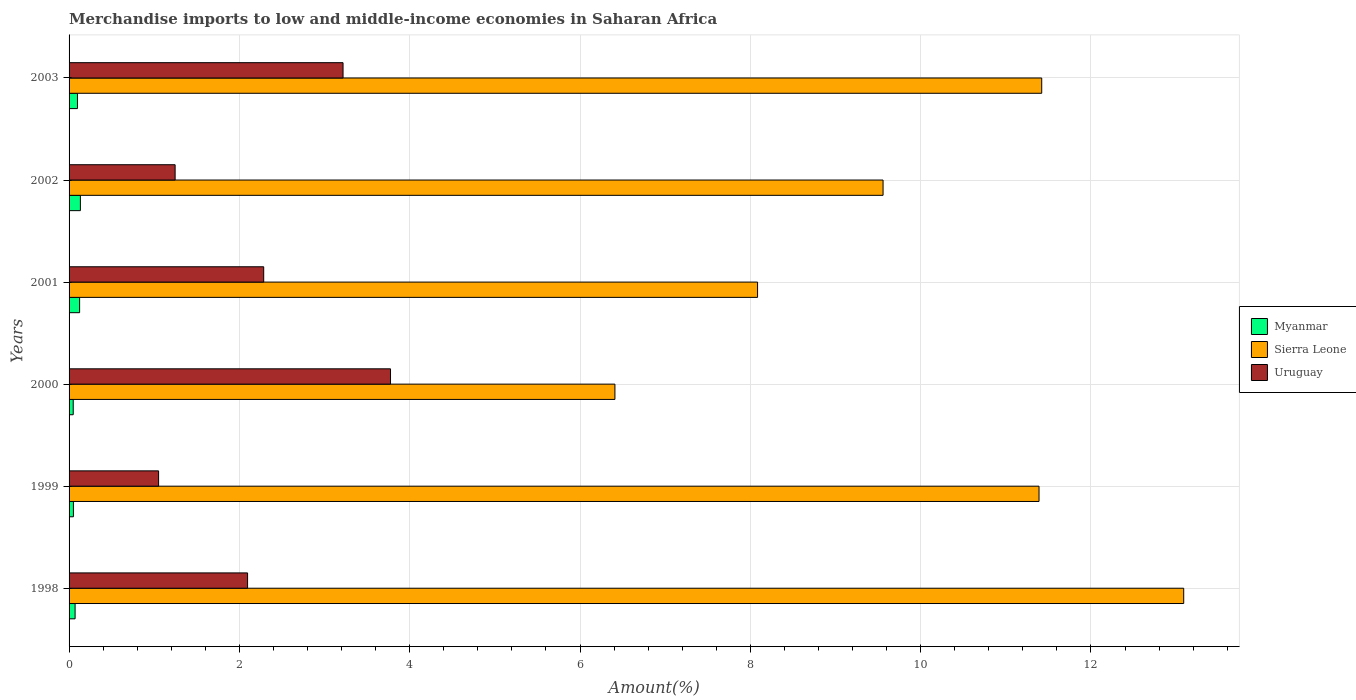How many groups of bars are there?
Provide a succinct answer. 6. In how many cases, is the number of bars for a given year not equal to the number of legend labels?
Provide a succinct answer. 0. What is the percentage of amount earned from merchandise imports in Uruguay in 1999?
Provide a succinct answer. 1.05. Across all years, what is the maximum percentage of amount earned from merchandise imports in Myanmar?
Provide a short and direct response. 0.13. Across all years, what is the minimum percentage of amount earned from merchandise imports in Myanmar?
Offer a terse response. 0.05. In which year was the percentage of amount earned from merchandise imports in Uruguay maximum?
Give a very brief answer. 2000. What is the total percentage of amount earned from merchandise imports in Uruguay in the graph?
Ensure brevity in your answer.  13.67. What is the difference between the percentage of amount earned from merchandise imports in Myanmar in 2000 and that in 2002?
Ensure brevity in your answer.  -0.08. What is the difference between the percentage of amount earned from merchandise imports in Sierra Leone in 2000 and the percentage of amount earned from merchandise imports in Myanmar in 2003?
Keep it short and to the point. 6.31. What is the average percentage of amount earned from merchandise imports in Myanmar per year?
Offer a terse response. 0.09. In the year 2003, what is the difference between the percentage of amount earned from merchandise imports in Myanmar and percentage of amount earned from merchandise imports in Uruguay?
Your answer should be very brief. -3.12. In how many years, is the percentage of amount earned from merchandise imports in Sierra Leone greater than 4 %?
Offer a terse response. 6. What is the ratio of the percentage of amount earned from merchandise imports in Myanmar in 2001 to that in 2002?
Ensure brevity in your answer.  0.93. Is the difference between the percentage of amount earned from merchandise imports in Myanmar in 1999 and 2002 greater than the difference between the percentage of amount earned from merchandise imports in Uruguay in 1999 and 2002?
Make the answer very short. Yes. What is the difference between the highest and the second highest percentage of amount earned from merchandise imports in Uruguay?
Your response must be concise. 0.56. What is the difference between the highest and the lowest percentage of amount earned from merchandise imports in Sierra Leone?
Provide a succinct answer. 6.68. In how many years, is the percentage of amount earned from merchandise imports in Uruguay greater than the average percentage of amount earned from merchandise imports in Uruguay taken over all years?
Provide a short and direct response. 3. What does the 1st bar from the top in 2000 represents?
Your answer should be compact. Uruguay. What does the 3rd bar from the bottom in 2000 represents?
Your response must be concise. Uruguay. Is it the case that in every year, the sum of the percentage of amount earned from merchandise imports in Sierra Leone and percentage of amount earned from merchandise imports in Uruguay is greater than the percentage of amount earned from merchandise imports in Myanmar?
Offer a very short reply. Yes. How many bars are there?
Ensure brevity in your answer.  18. Are all the bars in the graph horizontal?
Keep it short and to the point. Yes. Does the graph contain grids?
Provide a succinct answer. Yes. How many legend labels are there?
Provide a succinct answer. 3. What is the title of the graph?
Your answer should be very brief. Merchandise imports to low and middle-income economies in Saharan Africa. Does "Palau" appear as one of the legend labels in the graph?
Give a very brief answer. No. What is the label or title of the X-axis?
Your response must be concise. Amount(%). What is the Amount(%) of Myanmar in 1998?
Give a very brief answer. 0.07. What is the Amount(%) in Sierra Leone in 1998?
Offer a very short reply. 13.09. What is the Amount(%) in Uruguay in 1998?
Provide a short and direct response. 2.1. What is the Amount(%) of Myanmar in 1999?
Your answer should be compact. 0.05. What is the Amount(%) in Sierra Leone in 1999?
Ensure brevity in your answer.  11.39. What is the Amount(%) in Uruguay in 1999?
Offer a terse response. 1.05. What is the Amount(%) in Myanmar in 2000?
Your answer should be compact. 0.05. What is the Amount(%) of Sierra Leone in 2000?
Offer a very short reply. 6.41. What is the Amount(%) of Uruguay in 2000?
Offer a very short reply. 3.77. What is the Amount(%) in Myanmar in 2001?
Your answer should be very brief. 0.12. What is the Amount(%) in Sierra Leone in 2001?
Offer a very short reply. 8.09. What is the Amount(%) of Uruguay in 2001?
Provide a short and direct response. 2.29. What is the Amount(%) in Myanmar in 2002?
Give a very brief answer. 0.13. What is the Amount(%) of Sierra Leone in 2002?
Keep it short and to the point. 9.56. What is the Amount(%) in Uruguay in 2002?
Offer a very short reply. 1.25. What is the Amount(%) of Myanmar in 2003?
Give a very brief answer. 0.1. What is the Amount(%) of Sierra Leone in 2003?
Provide a short and direct response. 11.42. What is the Amount(%) of Uruguay in 2003?
Ensure brevity in your answer.  3.22. Across all years, what is the maximum Amount(%) in Myanmar?
Keep it short and to the point. 0.13. Across all years, what is the maximum Amount(%) of Sierra Leone?
Provide a succinct answer. 13.09. Across all years, what is the maximum Amount(%) in Uruguay?
Your response must be concise. 3.77. Across all years, what is the minimum Amount(%) of Myanmar?
Ensure brevity in your answer.  0.05. Across all years, what is the minimum Amount(%) in Sierra Leone?
Provide a succinct answer. 6.41. Across all years, what is the minimum Amount(%) of Uruguay?
Offer a terse response. 1.05. What is the total Amount(%) in Myanmar in the graph?
Your answer should be very brief. 0.53. What is the total Amount(%) in Sierra Leone in the graph?
Your answer should be very brief. 59.96. What is the total Amount(%) of Uruguay in the graph?
Make the answer very short. 13.67. What is the difference between the Amount(%) of Myanmar in 1998 and that in 1999?
Your answer should be compact. 0.02. What is the difference between the Amount(%) of Sierra Leone in 1998 and that in 1999?
Give a very brief answer. 1.7. What is the difference between the Amount(%) in Uruguay in 1998 and that in 1999?
Your answer should be compact. 1.04. What is the difference between the Amount(%) in Myanmar in 1998 and that in 2000?
Your answer should be compact. 0.02. What is the difference between the Amount(%) of Sierra Leone in 1998 and that in 2000?
Provide a short and direct response. 6.68. What is the difference between the Amount(%) of Uruguay in 1998 and that in 2000?
Provide a succinct answer. -1.68. What is the difference between the Amount(%) in Myanmar in 1998 and that in 2001?
Ensure brevity in your answer.  -0.05. What is the difference between the Amount(%) of Sierra Leone in 1998 and that in 2001?
Keep it short and to the point. 5. What is the difference between the Amount(%) of Uruguay in 1998 and that in 2001?
Your response must be concise. -0.19. What is the difference between the Amount(%) in Myanmar in 1998 and that in 2002?
Your answer should be compact. -0.06. What is the difference between the Amount(%) of Sierra Leone in 1998 and that in 2002?
Provide a succinct answer. 3.53. What is the difference between the Amount(%) in Uruguay in 1998 and that in 2002?
Provide a succinct answer. 0.85. What is the difference between the Amount(%) of Myanmar in 1998 and that in 2003?
Ensure brevity in your answer.  -0.03. What is the difference between the Amount(%) in Sierra Leone in 1998 and that in 2003?
Your answer should be compact. 1.67. What is the difference between the Amount(%) in Uruguay in 1998 and that in 2003?
Offer a terse response. -1.12. What is the difference between the Amount(%) in Myanmar in 1999 and that in 2000?
Provide a short and direct response. 0. What is the difference between the Amount(%) of Sierra Leone in 1999 and that in 2000?
Provide a short and direct response. 4.98. What is the difference between the Amount(%) of Uruguay in 1999 and that in 2000?
Your response must be concise. -2.72. What is the difference between the Amount(%) in Myanmar in 1999 and that in 2001?
Make the answer very short. -0.07. What is the difference between the Amount(%) in Sierra Leone in 1999 and that in 2001?
Offer a very short reply. 3.31. What is the difference between the Amount(%) of Uruguay in 1999 and that in 2001?
Offer a terse response. -1.23. What is the difference between the Amount(%) of Myanmar in 1999 and that in 2002?
Provide a succinct answer. -0.08. What is the difference between the Amount(%) of Sierra Leone in 1999 and that in 2002?
Keep it short and to the point. 1.83. What is the difference between the Amount(%) of Uruguay in 1999 and that in 2002?
Your response must be concise. -0.19. What is the difference between the Amount(%) in Myanmar in 1999 and that in 2003?
Provide a short and direct response. -0.05. What is the difference between the Amount(%) of Sierra Leone in 1999 and that in 2003?
Provide a short and direct response. -0.03. What is the difference between the Amount(%) of Uruguay in 1999 and that in 2003?
Your answer should be very brief. -2.17. What is the difference between the Amount(%) in Myanmar in 2000 and that in 2001?
Give a very brief answer. -0.08. What is the difference between the Amount(%) of Sierra Leone in 2000 and that in 2001?
Provide a short and direct response. -1.68. What is the difference between the Amount(%) in Uruguay in 2000 and that in 2001?
Offer a terse response. 1.49. What is the difference between the Amount(%) in Myanmar in 2000 and that in 2002?
Provide a short and direct response. -0.08. What is the difference between the Amount(%) in Sierra Leone in 2000 and that in 2002?
Ensure brevity in your answer.  -3.15. What is the difference between the Amount(%) in Uruguay in 2000 and that in 2002?
Give a very brief answer. 2.53. What is the difference between the Amount(%) of Myanmar in 2000 and that in 2003?
Make the answer very short. -0.05. What is the difference between the Amount(%) in Sierra Leone in 2000 and that in 2003?
Your response must be concise. -5.01. What is the difference between the Amount(%) in Uruguay in 2000 and that in 2003?
Give a very brief answer. 0.56. What is the difference between the Amount(%) of Myanmar in 2001 and that in 2002?
Your answer should be very brief. -0.01. What is the difference between the Amount(%) of Sierra Leone in 2001 and that in 2002?
Offer a very short reply. -1.47. What is the difference between the Amount(%) of Uruguay in 2001 and that in 2002?
Ensure brevity in your answer.  1.04. What is the difference between the Amount(%) of Myanmar in 2001 and that in 2003?
Give a very brief answer. 0.03. What is the difference between the Amount(%) in Sierra Leone in 2001 and that in 2003?
Your answer should be compact. -3.34. What is the difference between the Amount(%) in Uruguay in 2001 and that in 2003?
Keep it short and to the point. -0.93. What is the difference between the Amount(%) of Myanmar in 2002 and that in 2003?
Give a very brief answer. 0.03. What is the difference between the Amount(%) in Sierra Leone in 2002 and that in 2003?
Your answer should be very brief. -1.86. What is the difference between the Amount(%) of Uruguay in 2002 and that in 2003?
Offer a very short reply. -1.97. What is the difference between the Amount(%) of Myanmar in 1998 and the Amount(%) of Sierra Leone in 1999?
Your response must be concise. -11.32. What is the difference between the Amount(%) of Myanmar in 1998 and the Amount(%) of Uruguay in 1999?
Provide a short and direct response. -0.98. What is the difference between the Amount(%) in Sierra Leone in 1998 and the Amount(%) in Uruguay in 1999?
Your answer should be very brief. 12.04. What is the difference between the Amount(%) in Myanmar in 1998 and the Amount(%) in Sierra Leone in 2000?
Provide a short and direct response. -6.34. What is the difference between the Amount(%) of Myanmar in 1998 and the Amount(%) of Uruguay in 2000?
Offer a very short reply. -3.7. What is the difference between the Amount(%) of Sierra Leone in 1998 and the Amount(%) of Uruguay in 2000?
Provide a short and direct response. 9.31. What is the difference between the Amount(%) of Myanmar in 1998 and the Amount(%) of Sierra Leone in 2001?
Provide a short and direct response. -8.01. What is the difference between the Amount(%) in Myanmar in 1998 and the Amount(%) in Uruguay in 2001?
Your answer should be very brief. -2.21. What is the difference between the Amount(%) of Sierra Leone in 1998 and the Amount(%) of Uruguay in 2001?
Offer a very short reply. 10.8. What is the difference between the Amount(%) of Myanmar in 1998 and the Amount(%) of Sierra Leone in 2002?
Your answer should be very brief. -9.49. What is the difference between the Amount(%) of Myanmar in 1998 and the Amount(%) of Uruguay in 2002?
Your answer should be compact. -1.17. What is the difference between the Amount(%) of Sierra Leone in 1998 and the Amount(%) of Uruguay in 2002?
Keep it short and to the point. 11.84. What is the difference between the Amount(%) of Myanmar in 1998 and the Amount(%) of Sierra Leone in 2003?
Make the answer very short. -11.35. What is the difference between the Amount(%) in Myanmar in 1998 and the Amount(%) in Uruguay in 2003?
Your response must be concise. -3.15. What is the difference between the Amount(%) of Sierra Leone in 1998 and the Amount(%) of Uruguay in 2003?
Make the answer very short. 9.87. What is the difference between the Amount(%) of Myanmar in 1999 and the Amount(%) of Sierra Leone in 2000?
Ensure brevity in your answer.  -6.36. What is the difference between the Amount(%) in Myanmar in 1999 and the Amount(%) in Uruguay in 2000?
Keep it short and to the point. -3.72. What is the difference between the Amount(%) of Sierra Leone in 1999 and the Amount(%) of Uruguay in 2000?
Provide a succinct answer. 7.62. What is the difference between the Amount(%) in Myanmar in 1999 and the Amount(%) in Sierra Leone in 2001?
Offer a terse response. -8.03. What is the difference between the Amount(%) of Myanmar in 1999 and the Amount(%) of Uruguay in 2001?
Provide a short and direct response. -2.23. What is the difference between the Amount(%) of Sierra Leone in 1999 and the Amount(%) of Uruguay in 2001?
Offer a terse response. 9.1. What is the difference between the Amount(%) in Myanmar in 1999 and the Amount(%) in Sierra Leone in 2002?
Make the answer very short. -9.51. What is the difference between the Amount(%) in Myanmar in 1999 and the Amount(%) in Uruguay in 2002?
Your response must be concise. -1.19. What is the difference between the Amount(%) in Sierra Leone in 1999 and the Amount(%) in Uruguay in 2002?
Ensure brevity in your answer.  10.14. What is the difference between the Amount(%) in Myanmar in 1999 and the Amount(%) in Sierra Leone in 2003?
Your answer should be very brief. -11.37. What is the difference between the Amount(%) in Myanmar in 1999 and the Amount(%) in Uruguay in 2003?
Your response must be concise. -3.17. What is the difference between the Amount(%) in Sierra Leone in 1999 and the Amount(%) in Uruguay in 2003?
Your answer should be compact. 8.17. What is the difference between the Amount(%) of Myanmar in 2000 and the Amount(%) of Sierra Leone in 2001?
Provide a short and direct response. -8.04. What is the difference between the Amount(%) of Myanmar in 2000 and the Amount(%) of Uruguay in 2001?
Provide a short and direct response. -2.24. What is the difference between the Amount(%) of Sierra Leone in 2000 and the Amount(%) of Uruguay in 2001?
Offer a very short reply. 4.12. What is the difference between the Amount(%) in Myanmar in 2000 and the Amount(%) in Sierra Leone in 2002?
Provide a short and direct response. -9.51. What is the difference between the Amount(%) of Myanmar in 2000 and the Amount(%) of Uruguay in 2002?
Your answer should be very brief. -1.2. What is the difference between the Amount(%) in Sierra Leone in 2000 and the Amount(%) in Uruguay in 2002?
Your response must be concise. 5.16. What is the difference between the Amount(%) in Myanmar in 2000 and the Amount(%) in Sierra Leone in 2003?
Your answer should be very brief. -11.37. What is the difference between the Amount(%) in Myanmar in 2000 and the Amount(%) in Uruguay in 2003?
Your response must be concise. -3.17. What is the difference between the Amount(%) in Sierra Leone in 2000 and the Amount(%) in Uruguay in 2003?
Your response must be concise. 3.19. What is the difference between the Amount(%) of Myanmar in 2001 and the Amount(%) of Sierra Leone in 2002?
Ensure brevity in your answer.  -9.44. What is the difference between the Amount(%) of Myanmar in 2001 and the Amount(%) of Uruguay in 2002?
Give a very brief answer. -1.12. What is the difference between the Amount(%) of Sierra Leone in 2001 and the Amount(%) of Uruguay in 2002?
Make the answer very short. 6.84. What is the difference between the Amount(%) of Myanmar in 2001 and the Amount(%) of Sierra Leone in 2003?
Make the answer very short. -11.3. What is the difference between the Amount(%) in Myanmar in 2001 and the Amount(%) in Uruguay in 2003?
Your response must be concise. -3.09. What is the difference between the Amount(%) of Sierra Leone in 2001 and the Amount(%) of Uruguay in 2003?
Give a very brief answer. 4.87. What is the difference between the Amount(%) in Myanmar in 2002 and the Amount(%) in Sierra Leone in 2003?
Provide a succinct answer. -11.29. What is the difference between the Amount(%) of Myanmar in 2002 and the Amount(%) of Uruguay in 2003?
Make the answer very short. -3.08. What is the difference between the Amount(%) of Sierra Leone in 2002 and the Amount(%) of Uruguay in 2003?
Make the answer very short. 6.34. What is the average Amount(%) in Myanmar per year?
Make the answer very short. 0.09. What is the average Amount(%) in Sierra Leone per year?
Provide a short and direct response. 9.99. What is the average Amount(%) of Uruguay per year?
Keep it short and to the point. 2.28. In the year 1998, what is the difference between the Amount(%) of Myanmar and Amount(%) of Sierra Leone?
Ensure brevity in your answer.  -13.02. In the year 1998, what is the difference between the Amount(%) in Myanmar and Amount(%) in Uruguay?
Ensure brevity in your answer.  -2.03. In the year 1998, what is the difference between the Amount(%) of Sierra Leone and Amount(%) of Uruguay?
Your response must be concise. 10.99. In the year 1999, what is the difference between the Amount(%) in Myanmar and Amount(%) in Sierra Leone?
Give a very brief answer. -11.34. In the year 1999, what is the difference between the Amount(%) of Myanmar and Amount(%) of Uruguay?
Offer a very short reply. -1. In the year 1999, what is the difference between the Amount(%) in Sierra Leone and Amount(%) in Uruguay?
Ensure brevity in your answer.  10.34. In the year 2000, what is the difference between the Amount(%) in Myanmar and Amount(%) in Sierra Leone?
Your response must be concise. -6.36. In the year 2000, what is the difference between the Amount(%) of Myanmar and Amount(%) of Uruguay?
Provide a short and direct response. -3.73. In the year 2000, what is the difference between the Amount(%) of Sierra Leone and Amount(%) of Uruguay?
Provide a succinct answer. 2.64. In the year 2001, what is the difference between the Amount(%) of Myanmar and Amount(%) of Sierra Leone?
Make the answer very short. -7.96. In the year 2001, what is the difference between the Amount(%) in Myanmar and Amount(%) in Uruguay?
Give a very brief answer. -2.16. In the year 2001, what is the difference between the Amount(%) of Sierra Leone and Amount(%) of Uruguay?
Make the answer very short. 5.8. In the year 2002, what is the difference between the Amount(%) in Myanmar and Amount(%) in Sierra Leone?
Offer a terse response. -9.43. In the year 2002, what is the difference between the Amount(%) in Myanmar and Amount(%) in Uruguay?
Give a very brief answer. -1.11. In the year 2002, what is the difference between the Amount(%) in Sierra Leone and Amount(%) in Uruguay?
Ensure brevity in your answer.  8.31. In the year 2003, what is the difference between the Amount(%) of Myanmar and Amount(%) of Sierra Leone?
Offer a terse response. -11.32. In the year 2003, what is the difference between the Amount(%) of Myanmar and Amount(%) of Uruguay?
Keep it short and to the point. -3.12. In the year 2003, what is the difference between the Amount(%) in Sierra Leone and Amount(%) in Uruguay?
Your answer should be compact. 8.2. What is the ratio of the Amount(%) of Myanmar in 1998 to that in 1999?
Keep it short and to the point. 1.39. What is the ratio of the Amount(%) of Sierra Leone in 1998 to that in 1999?
Make the answer very short. 1.15. What is the ratio of the Amount(%) in Uruguay in 1998 to that in 1999?
Keep it short and to the point. 1.99. What is the ratio of the Amount(%) of Myanmar in 1998 to that in 2000?
Your answer should be compact. 1.45. What is the ratio of the Amount(%) of Sierra Leone in 1998 to that in 2000?
Make the answer very short. 2.04. What is the ratio of the Amount(%) in Uruguay in 1998 to that in 2000?
Offer a terse response. 0.56. What is the ratio of the Amount(%) of Myanmar in 1998 to that in 2001?
Offer a terse response. 0.57. What is the ratio of the Amount(%) of Sierra Leone in 1998 to that in 2001?
Give a very brief answer. 1.62. What is the ratio of the Amount(%) in Uruguay in 1998 to that in 2001?
Offer a very short reply. 0.92. What is the ratio of the Amount(%) of Myanmar in 1998 to that in 2002?
Offer a very short reply. 0.53. What is the ratio of the Amount(%) of Sierra Leone in 1998 to that in 2002?
Provide a succinct answer. 1.37. What is the ratio of the Amount(%) of Uruguay in 1998 to that in 2002?
Your answer should be compact. 1.68. What is the ratio of the Amount(%) of Myanmar in 1998 to that in 2003?
Your response must be concise. 0.72. What is the ratio of the Amount(%) of Sierra Leone in 1998 to that in 2003?
Ensure brevity in your answer.  1.15. What is the ratio of the Amount(%) in Uruguay in 1998 to that in 2003?
Offer a very short reply. 0.65. What is the ratio of the Amount(%) in Myanmar in 1999 to that in 2000?
Keep it short and to the point. 1.05. What is the ratio of the Amount(%) in Sierra Leone in 1999 to that in 2000?
Make the answer very short. 1.78. What is the ratio of the Amount(%) in Uruguay in 1999 to that in 2000?
Ensure brevity in your answer.  0.28. What is the ratio of the Amount(%) in Myanmar in 1999 to that in 2001?
Your response must be concise. 0.41. What is the ratio of the Amount(%) in Sierra Leone in 1999 to that in 2001?
Give a very brief answer. 1.41. What is the ratio of the Amount(%) of Uruguay in 1999 to that in 2001?
Your response must be concise. 0.46. What is the ratio of the Amount(%) in Myanmar in 1999 to that in 2002?
Offer a terse response. 0.38. What is the ratio of the Amount(%) of Sierra Leone in 1999 to that in 2002?
Your response must be concise. 1.19. What is the ratio of the Amount(%) in Uruguay in 1999 to that in 2002?
Provide a short and direct response. 0.84. What is the ratio of the Amount(%) in Myanmar in 1999 to that in 2003?
Your response must be concise. 0.52. What is the ratio of the Amount(%) in Uruguay in 1999 to that in 2003?
Make the answer very short. 0.33. What is the ratio of the Amount(%) of Myanmar in 2000 to that in 2001?
Your response must be concise. 0.39. What is the ratio of the Amount(%) in Sierra Leone in 2000 to that in 2001?
Your response must be concise. 0.79. What is the ratio of the Amount(%) in Uruguay in 2000 to that in 2001?
Your answer should be very brief. 1.65. What is the ratio of the Amount(%) of Myanmar in 2000 to that in 2002?
Provide a succinct answer. 0.37. What is the ratio of the Amount(%) of Sierra Leone in 2000 to that in 2002?
Keep it short and to the point. 0.67. What is the ratio of the Amount(%) of Uruguay in 2000 to that in 2002?
Keep it short and to the point. 3.03. What is the ratio of the Amount(%) of Myanmar in 2000 to that in 2003?
Your answer should be very brief. 0.49. What is the ratio of the Amount(%) of Sierra Leone in 2000 to that in 2003?
Provide a succinct answer. 0.56. What is the ratio of the Amount(%) in Uruguay in 2000 to that in 2003?
Offer a terse response. 1.17. What is the ratio of the Amount(%) of Myanmar in 2001 to that in 2002?
Ensure brevity in your answer.  0.93. What is the ratio of the Amount(%) in Sierra Leone in 2001 to that in 2002?
Offer a very short reply. 0.85. What is the ratio of the Amount(%) in Uruguay in 2001 to that in 2002?
Offer a very short reply. 1.84. What is the ratio of the Amount(%) in Myanmar in 2001 to that in 2003?
Give a very brief answer. 1.26. What is the ratio of the Amount(%) in Sierra Leone in 2001 to that in 2003?
Make the answer very short. 0.71. What is the ratio of the Amount(%) of Uruguay in 2001 to that in 2003?
Keep it short and to the point. 0.71. What is the ratio of the Amount(%) in Myanmar in 2002 to that in 2003?
Make the answer very short. 1.35. What is the ratio of the Amount(%) of Sierra Leone in 2002 to that in 2003?
Keep it short and to the point. 0.84. What is the ratio of the Amount(%) of Uruguay in 2002 to that in 2003?
Keep it short and to the point. 0.39. What is the difference between the highest and the second highest Amount(%) of Myanmar?
Provide a short and direct response. 0.01. What is the difference between the highest and the second highest Amount(%) in Sierra Leone?
Keep it short and to the point. 1.67. What is the difference between the highest and the second highest Amount(%) in Uruguay?
Offer a terse response. 0.56. What is the difference between the highest and the lowest Amount(%) of Myanmar?
Make the answer very short. 0.08. What is the difference between the highest and the lowest Amount(%) of Sierra Leone?
Offer a terse response. 6.68. What is the difference between the highest and the lowest Amount(%) of Uruguay?
Make the answer very short. 2.72. 